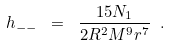<formula> <loc_0><loc_0><loc_500><loc_500>h _ { - - } \ = \ \frac { 1 5 N _ { 1 } } { 2 R ^ { 2 } M ^ { 9 } r ^ { 7 } } \ .</formula> 